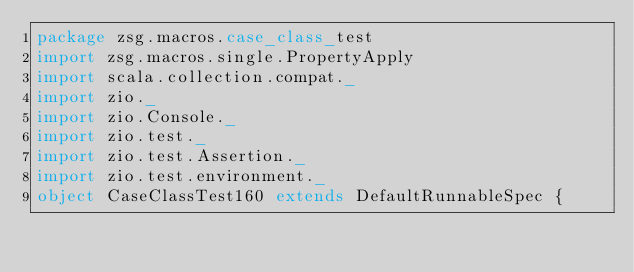<code> <loc_0><loc_0><loc_500><loc_500><_Scala_>package zsg.macros.case_class_test
import zsg.macros.single.PropertyApply
import scala.collection.compat._
import zio._
import zio.Console._
import zio.test._
import zio.test.Assertion._
import zio.test.environment._
object CaseClassTest160 extends DefaultRunnableSpec {</code> 